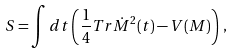<formula> <loc_0><loc_0><loc_500><loc_500>S = \int d t \left ( \frac { 1 } { 4 } T r \dot { M } ^ { 2 } ( t ) - V ( M ) \right ) \, ,</formula> 